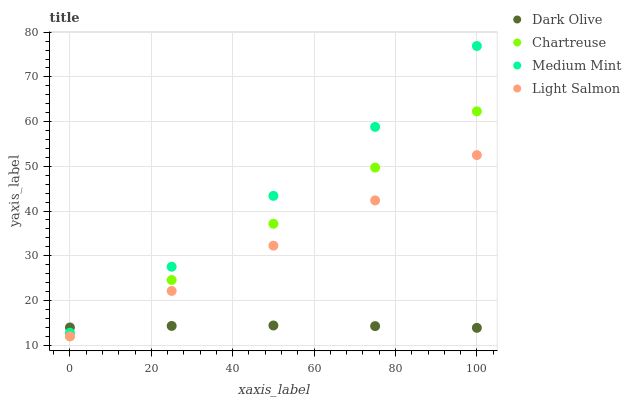Does Dark Olive have the minimum area under the curve?
Answer yes or no. Yes. Does Medium Mint have the maximum area under the curve?
Answer yes or no. Yes. Does Chartreuse have the minimum area under the curve?
Answer yes or no. No. Does Chartreuse have the maximum area under the curve?
Answer yes or no. No. Is Light Salmon the smoothest?
Answer yes or no. Yes. Is Medium Mint the roughest?
Answer yes or no. Yes. Is Chartreuse the smoothest?
Answer yes or no. No. Is Chartreuse the roughest?
Answer yes or no. No. Does Chartreuse have the lowest value?
Answer yes or no. Yes. Does Dark Olive have the lowest value?
Answer yes or no. No. Does Medium Mint have the highest value?
Answer yes or no. Yes. Does Chartreuse have the highest value?
Answer yes or no. No. Is Chartreuse less than Medium Mint?
Answer yes or no. Yes. Is Medium Mint greater than Light Salmon?
Answer yes or no. Yes. Does Light Salmon intersect Dark Olive?
Answer yes or no. Yes. Is Light Salmon less than Dark Olive?
Answer yes or no. No. Is Light Salmon greater than Dark Olive?
Answer yes or no. No. Does Chartreuse intersect Medium Mint?
Answer yes or no. No. 